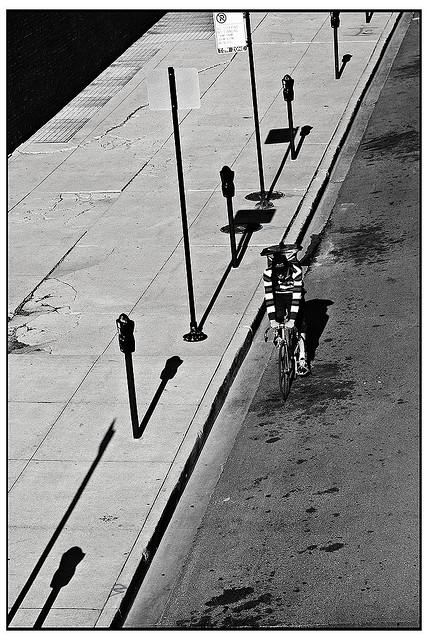What kind of vehicle is the person driving up next to the street? Please explain your reasoning. bike. They are riding a bicycle 